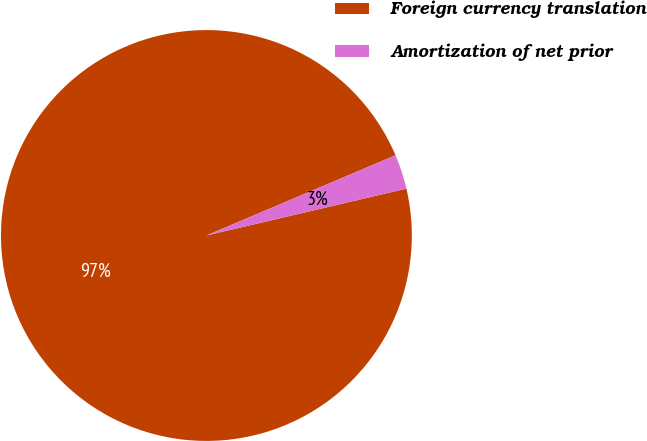Convert chart to OTSL. <chart><loc_0><loc_0><loc_500><loc_500><pie_chart><fcel>Foreign currency translation<fcel>Amortization of net prior<nl><fcel>97.28%<fcel>2.72%<nl></chart> 